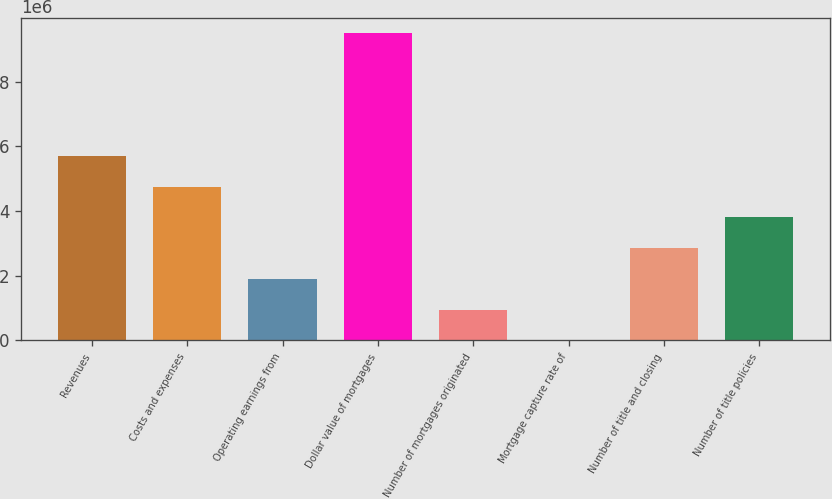Convert chart. <chart><loc_0><loc_0><loc_500><loc_500><bar_chart><fcel>Revenues<fcel>Costs and expenses<fcel>Operating earnings from<fcel>Dollar value of mortgages<fcel>Number of mortgages originated<fcel>Mortgage capture rate of<fcel>Number of title and closing<fcel>Number of title policies<nl><fcel>5.70543e+06<fcel>4.75453e+06<fcel>1.90185e+06<fcel>9.509e+06<fcel>950959<fcel>66<fcel>2.85275e+06<fcel>3.80364e+06<nl></chart> 